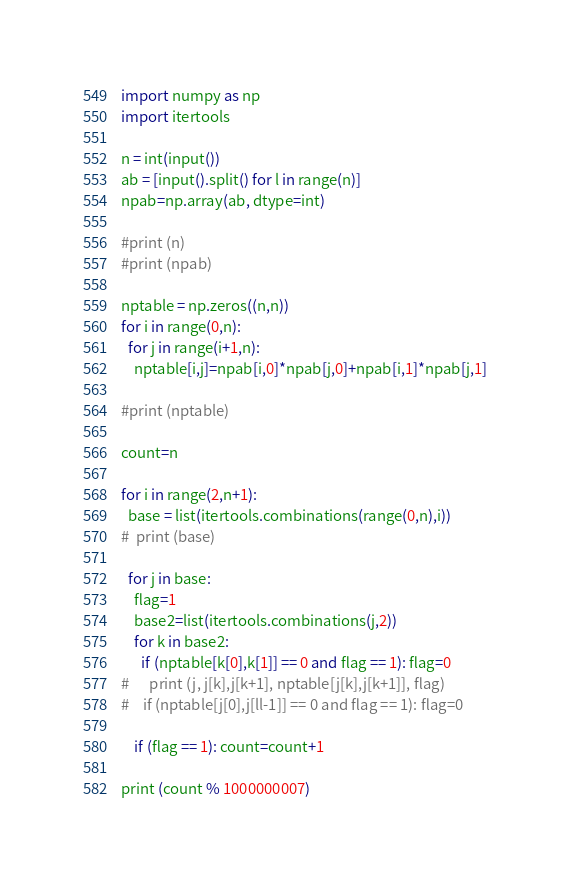<code> <loc_0><loc_0><loc_500><loc_500><_Python_>import numpy as np
import itertools

n = int(input())
ab = [input().split() for l in range(n)]
npab=np.array(ab, dtype=int)

#print (n)
#print (npab)

nptable = np.zeros((n,n))
for i in range(0,n):
  for j in range(i+1,n):
    nptable[i,j]=npab[i,0]*npab[j,0]+npab[i,1]*npab[j,1]

#print (nptable)

count=n

for i in range(2,n+1):
  base = list(itertools.combinations(range(0,n),i))
#  print (base)

  for j in base:
    flag=1
    base2=list(itertools.combinations(j,2))
    for k in base2:
      if (nptable[k[0],k[1]] == 0 and flag == 1): flag=0
#      print (j, j[k],j[k+1], nptable[j[k],j[k+1]], flag)
#    if (nptable[j[0],j[ll-1]] == 0 and flag == 1): flag=0
        
    if (flag == 1): count=count+1
    
print (count % 1000000007)</code> 